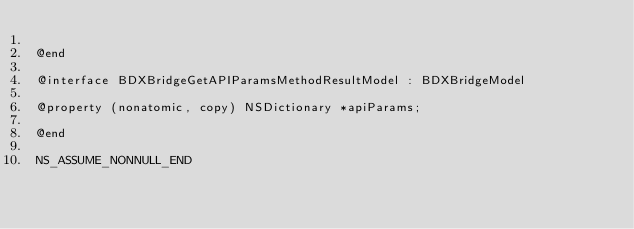<code> <loc_0><loc_0><loc_500><loc_500><_C_>
@end

@interface BDXBridgeGetAPIParamsMethodResultModel : BDXBridgeModel

@property (nonatomic, copy) NSDictionary *apiParams;

@end

NS_ASSUME_NONNULL_END
</code> 